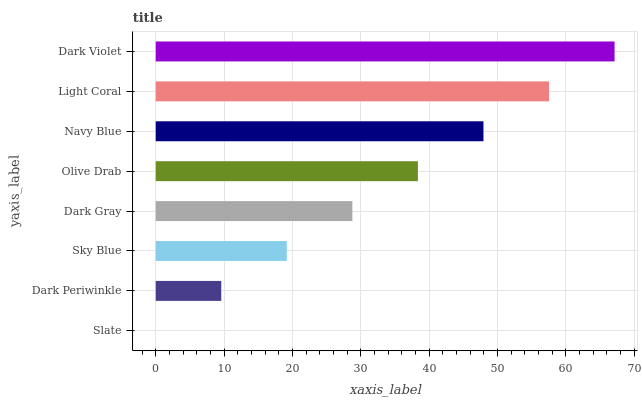Is Slate the minimum?
Answer yes or no. Yes. Is Dark Violet the maximum?
Answer yes or no. Yes. Is Dark Periwinkle the minimum?
Answer yes or no. No. Is Dark Periwinkle the maximum?
Answer yes or no. No. Is Dark Periwinkle greater than Slate?
Answer yes or no. Yes. Is Slate less than Dark Periwinkle?
Answer yes or no. Yes. Is Slate greater than Dark Periwinkle?
Answer yes or no. No. Is Dark Periwinkle less than Slate?
Answer yes or no. No. Is Olive Drab the high median?
Answer yes or no. Yes. Is Dark Gray the low median?
Answer yes or no. Yes. Is Navy Blue the high median?
Answer yes or no. No. Is Dark Violet the low median?
Answer yes or no. No. 